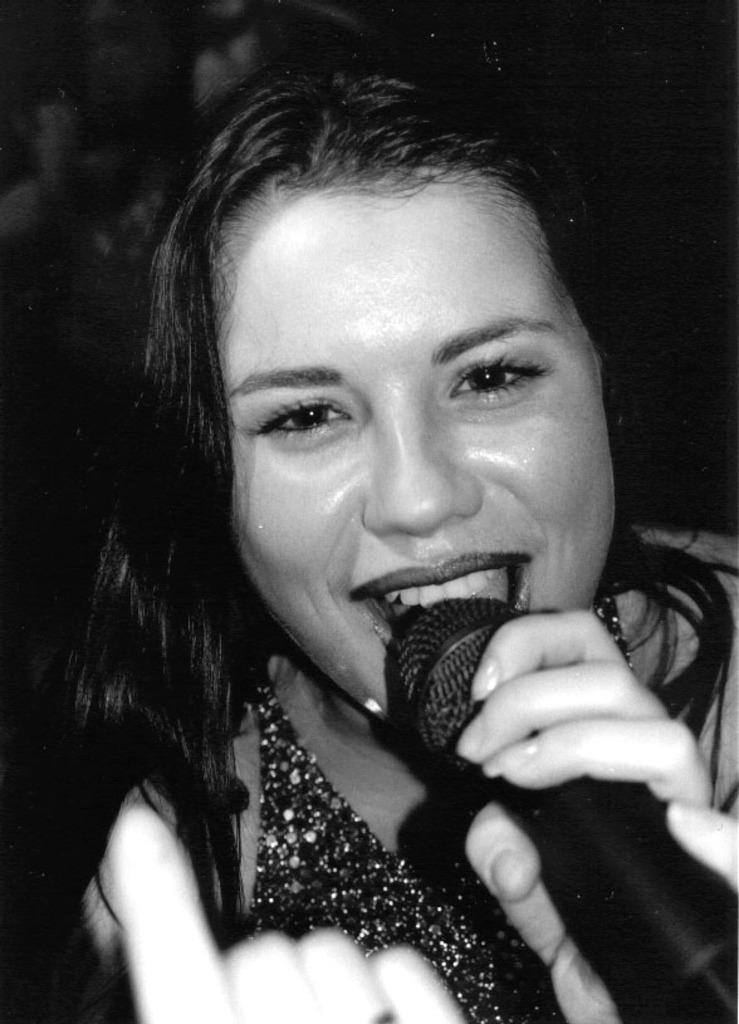What is the color scheme of the image? The image is black and white. Can you describe the person in the image? There is a lady in the image. What is the lady holding in the image? The lady is holding a microphone. What news station is the lady representing in the image? There is no indication of a news station or any affiliation in the image. 